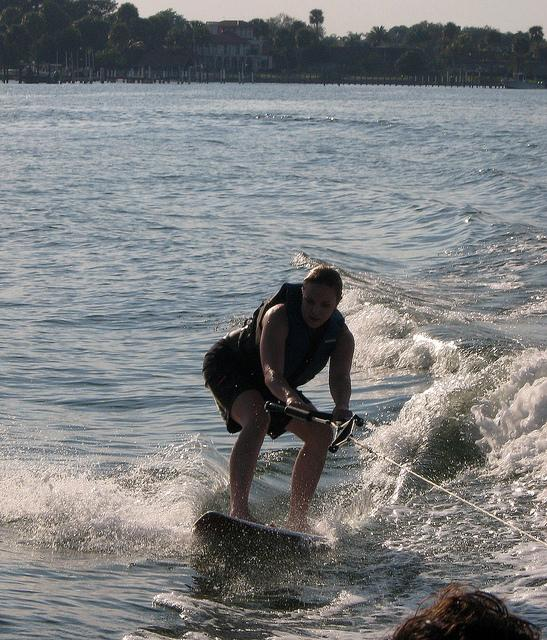What is the name of the safety garment the wakeboarder is wearing?

Choices:
A) shin guards
B) helmet
C) glasses
D) life vest life vest 